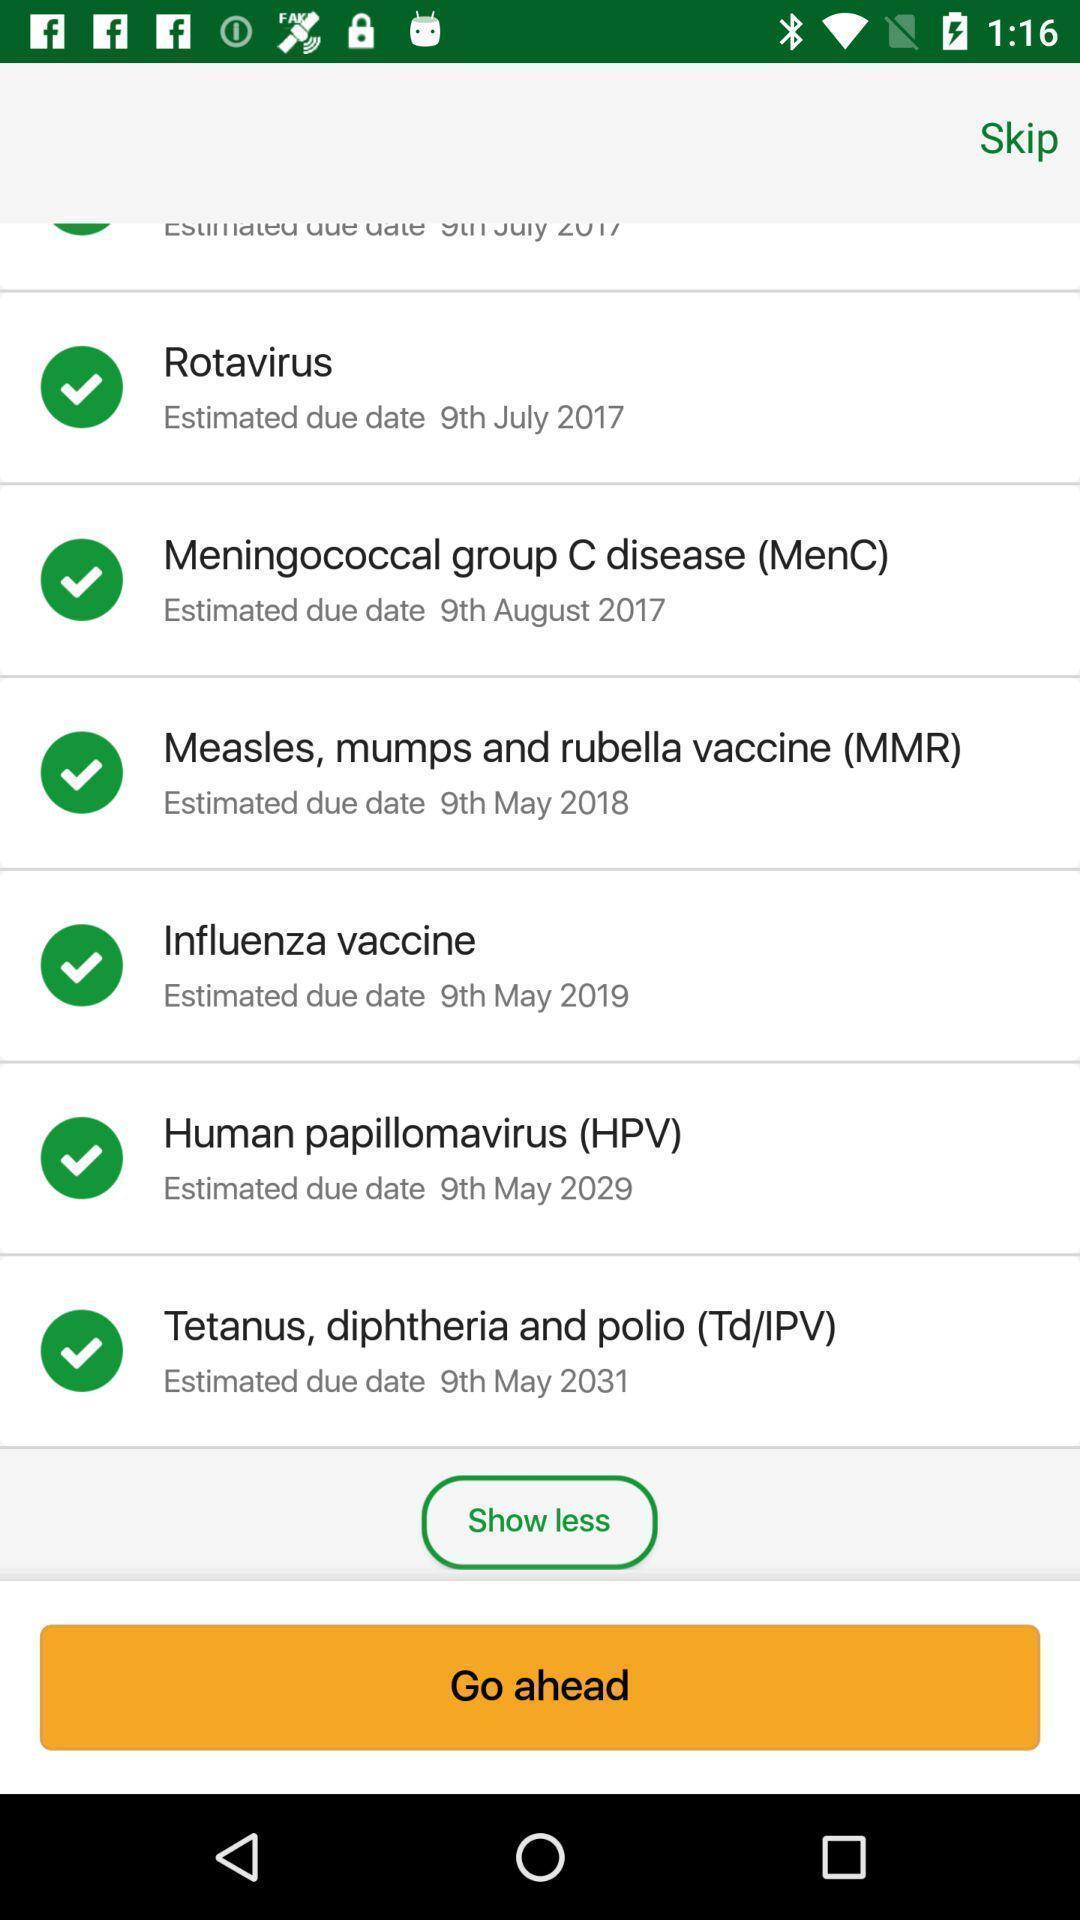What details can you identify in this image? Page displaying list of child vaccines in health app. 